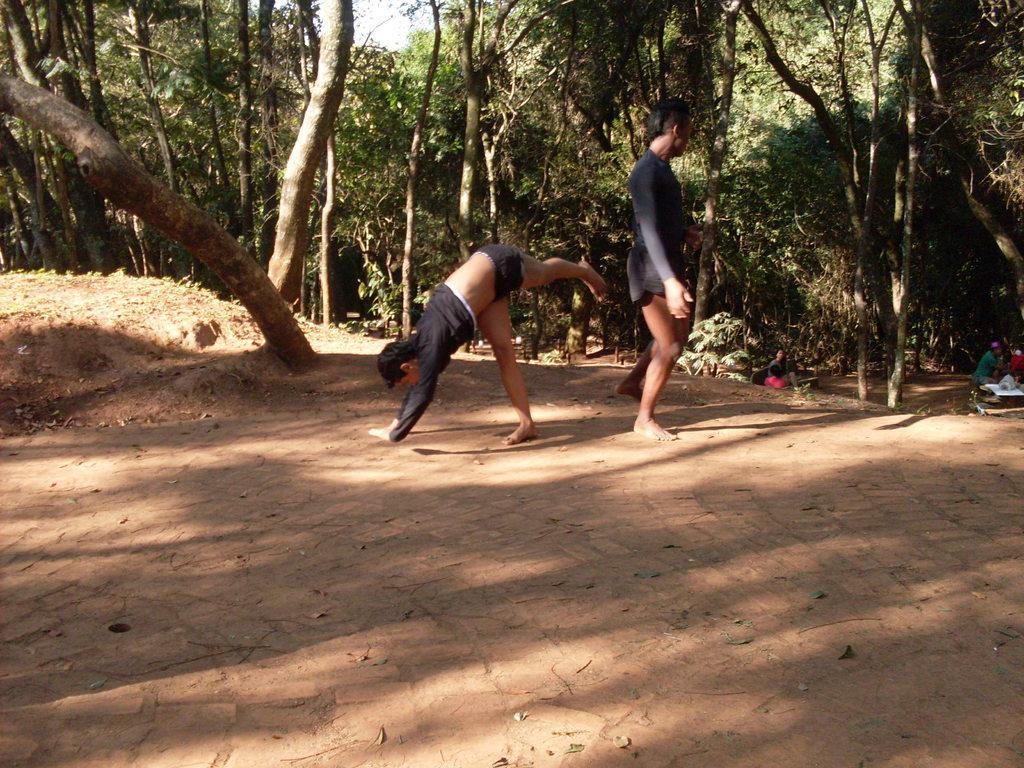How would you summarize this image in a sentence or two? In this picture there is a man who is wearing t-shirt and short. Beside him there is another man who is doing a stunt. In the background I can see many trees, plants and grass. On the right background I can see some people were standing near to the table. On the table I can see the plastic covers. At the top there is a sky. 